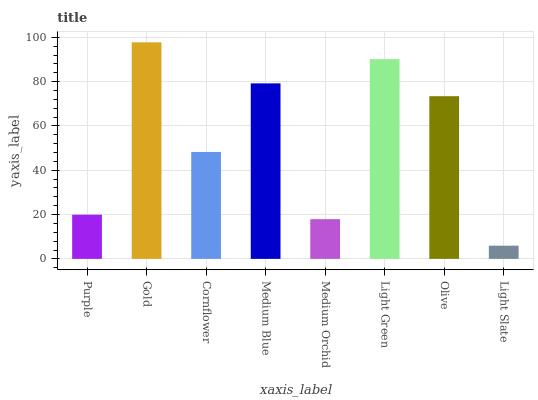Is Light Slate the minimum?
Answer yes or no. Yes. Is Gold the maximum?
Answer yes or no. Yes. Is Cornflower the minimum?
Answer yes or no. No. Is Cornflower the maximum?
Answer yes or no. No. Is Gold greater than Cornflower?
Answer yes or no. Yes. Is Cornflower less than Gold?
Answer yes or no. Yes. Is Cornflower greater than Gold?
Answer yes or no. No. Is Gold less than Cornflower?
Answer yes or no. No. Is Olive the high median?
Answer yes or no. Yes. Is Cornflower the low median?
Answer yes or no. Yes. Is Gold the high median?
Answer yes or no. No. Is Olive the low median?
Answer yes or no. No. 